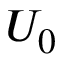<formula> <loc_0><loc_0><loc_500><loc_500>U _ { 0 }</formula> 